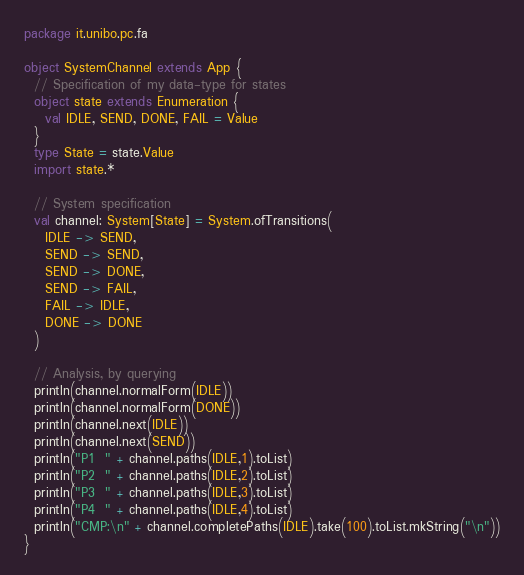<code> <loc_0><loc_0><loc_500><loc_500><_Scala_>package it.unibo.pc.fa

object SystemChannel extends App {
  // Specification of my data-type for states
  object state extends Enumeration {
    val IDLE, SEND, DONE, FAIL = Value
  }
  type State = state.Value
  import state.*

  // System specification
  val channel: System[State] = System.ofTransitions(
    IDLE -> SEND,
    SEND -> SEND,
    SEND -> DONE,
    SEND -> FAIL,
    FAIL -> IDLE,
    DONE -> DONE
  )

  // Analysis, by querying
  println(channel.normalForm(IDLE))
  println(channel.normalForm(DONE))
  println(channel.next(IDLE))
  println(channel.next(SEND))
  println("P1  " + channel.paths(IDLE,1).toList)
  println("P2  " + channel.paths(IDLE,2).toList)
  println("P3  " + channel.paths(IDLE,3).toList)
  println("P4  " + channel.paths(IDLE,4).toList)
  println("CMP:\n" + channel.completePaths(IDLE).take(100).toList.mkString("\n"))
}
</code> 